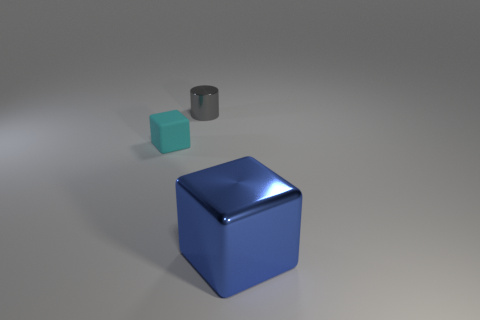Is there any other thing that has the same color as the metal cylinder?
Give a very brief answer. No. The object that is to the right of the rubber block and behind the blue metal object is what color?
Make the answer very short. Gray. Do the metal thing that is behind the blue metal object and the large object have the same size?
Give a very brief answer. No. Is the number of tiny metal cylinders that are behind the tiny cylinder greater than the number of cyan objects?
Offer a terse response. No. Do the blue thing and the tiny cyan matte object have the same shape?
Your response must be concise. Yes. How big is the blue metal thing?
Offer a terse response. Large. Are there more small cyan objects to the right of the small metallic cylinder than blue metal cubes in front of the large metal thing?
Give a very brief answer. No. Are there any large cubes on the right side of the shiny block?
Your response must be concise. No. Are there any blue rubber things that have the same size as the cyan object?
Offer a very short reply. No. There is a block that is made of the same material as the gray cylinder; what is its color?
Ensure brevity in your answer.  Blue. 